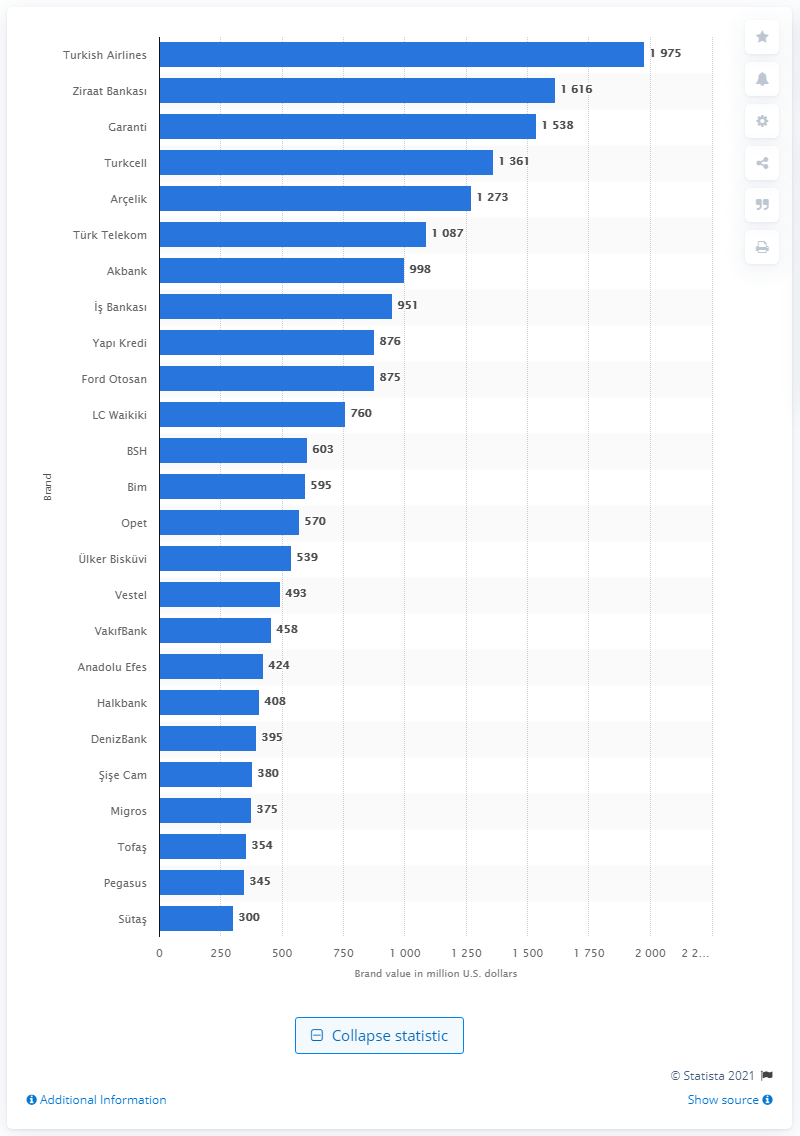Highlight a few significant elements in this photo. As of 2020, Turkish Airlines is the leading Turkish brand. 